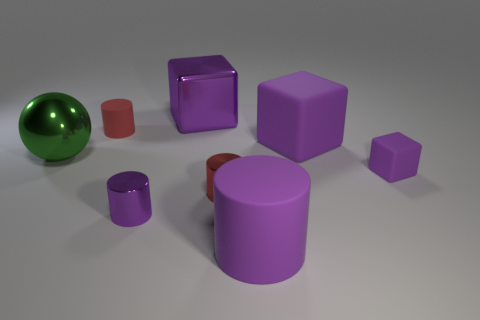What number of other objects are there of the same shape as the small purple rubber thing?
Give a very brief answer. 2. There is a large shiny object on the left side of the big metal cube; is its shape the same as the red matte object?
Offer a terse response. No. Are there any cubes in front of the large purple shiny cube?
Offer a very short reply. Yes. How many big things are either purple blocks or metallic cylinders?
Make the answer very short. 2. Are the green sphere and the large purple cylinder made of the same material?
Offer a very short reply. No. There is a shiny cube that is the same color as the big matte block; what is its size?
Provide a succinct answer. Large. Are there any things that have the same color as the large shiny cube?
Provide a succinct answer. Yes. There is a purple cylinder that is made of the same material as the green object; what is its size?
Keep it short and to the point. Small. What shape is the small purple thing to the left of the large purple cube that is to the right of the matte cylinder that is in front of the tiny cube?
Make the answer very short. Cylinder. There is a purple matte thing that is the same shape as the small purple shiny thing; what size is it?
Your response must be concise. Large. 